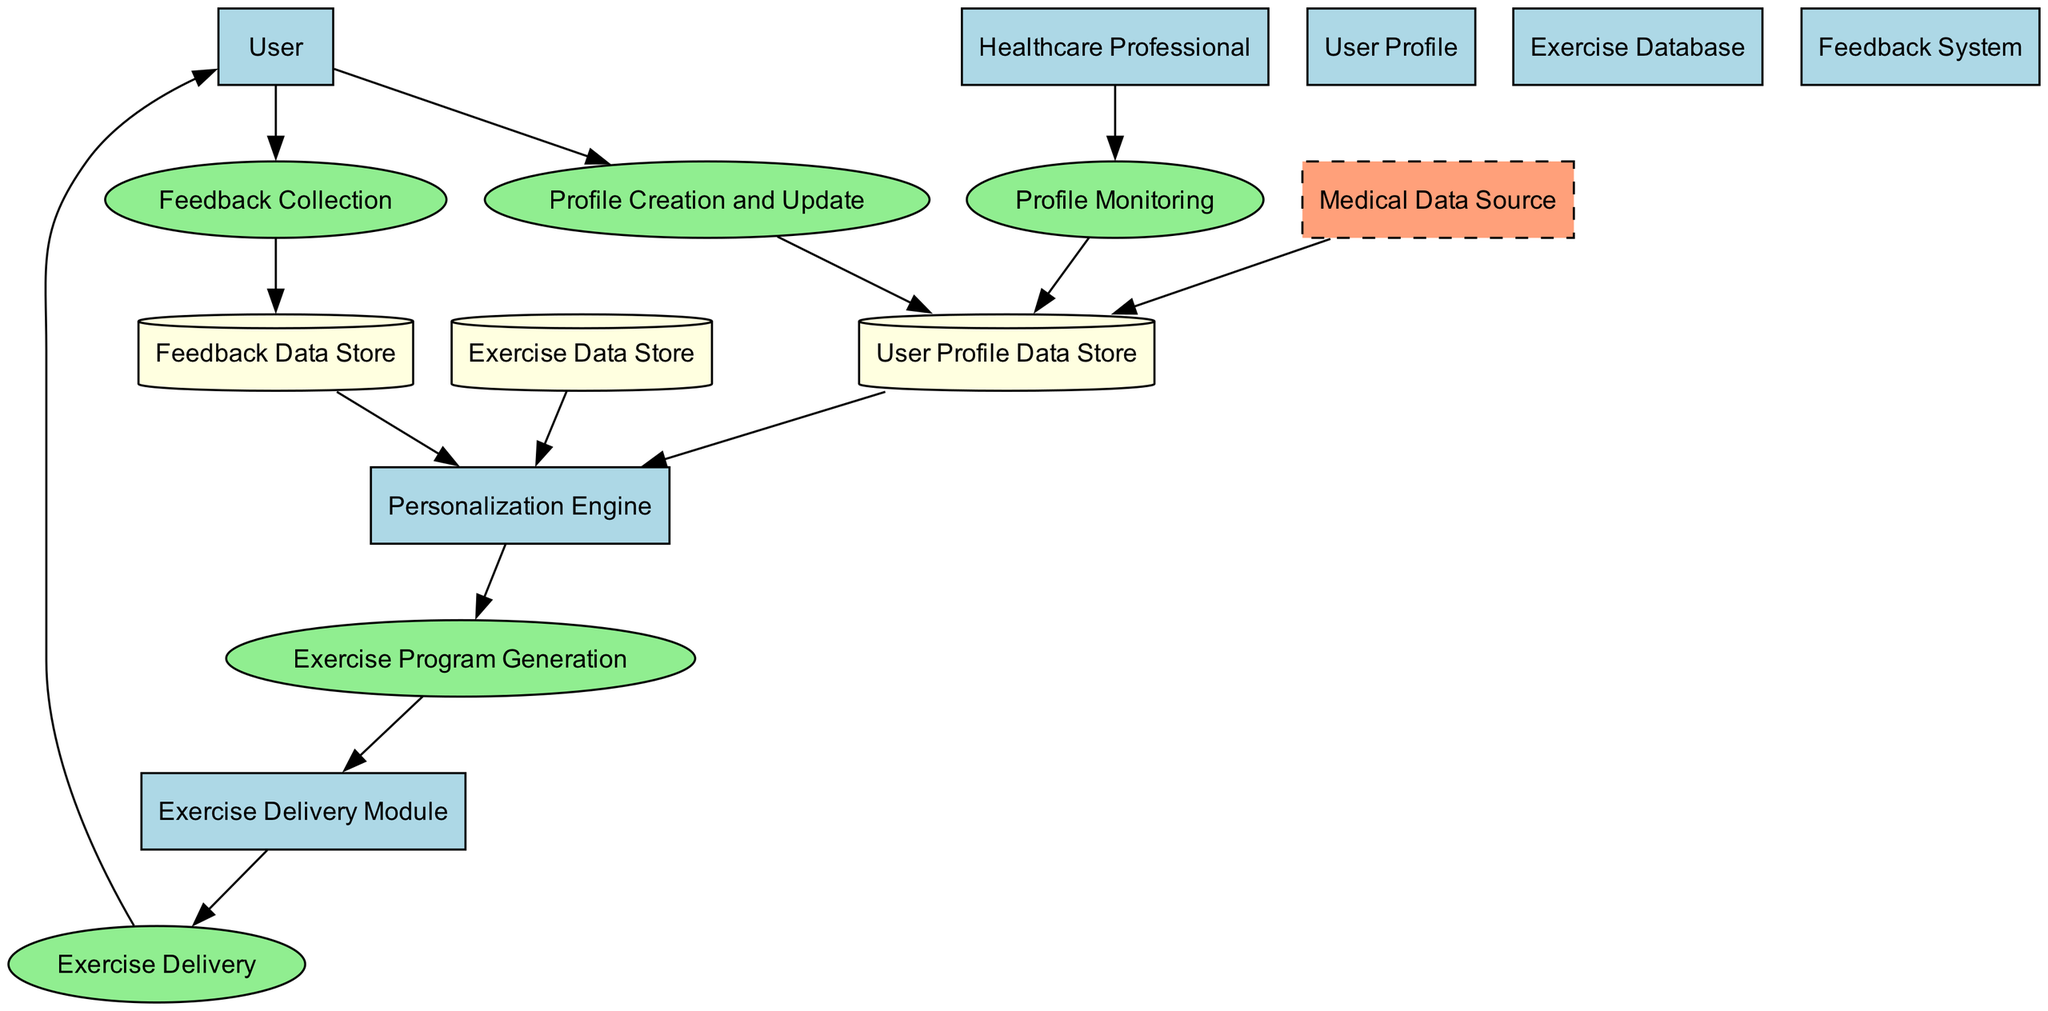What is the first process users engage with? The diagram indicates that the first process is "Profile Creation and Update," where users or healthcare professionals initially create or update the user's profile.
Answer: Profile Creation and Update How many external entities are present in the diagram? There is only one external entity represented in the diagram, which is "Medical Data Source."
Answer: 1 What is the purpose of the Feedback System? The Feedback System is designed to collect user feedback, which helps to refine and improve the personalization algorithm and exercise programs.
Answer: Collects user feedback Which module delivers the exercise program to users? According to the diagram, the "Exercise Delivery Module" is responsible for providing the tailored exercise program to users.
Answer: Exercise Delivery Module What relationship exists between the Exercise Data Store and the Personalization Engine? The diagram shows a direct flow from the "Exercise Data Store" to the "Personalization Engine," indicating that the Personalization Engine utilizes data from the Exercise Data Store to match exercises to user profiles.
Answer: Uses data from How does user feedback influence the system? User feedback collected through the "Feedback Collection" process is stored in the "Feedback Data Store," which then feeds back to the "Personalization Engine" to enhance future exercise programs.
Answer: Enhances future programs What is the connection between Healthcare Professional and User Profile Data Store? The "Healthcare Professional" is linked to the "Profile Monitoring" process, which updates the "User Profile Data Store" to reflect any changes in user progress monitored by healthcare professionals.
Answer: Updates user profiles Which process follows the Exercise Program Generation? The next step after "Exercise Program Generation" is the "Exercise Delivery" process, where the generated exercises are delivered to users.
Answer: Exercise Delivery What type of data is stored in Feedback Data Store? The "Feedback Data Store" specifically holds user feedback that has been collected regarding their experiences with the exercises.
Answer: User feedback 